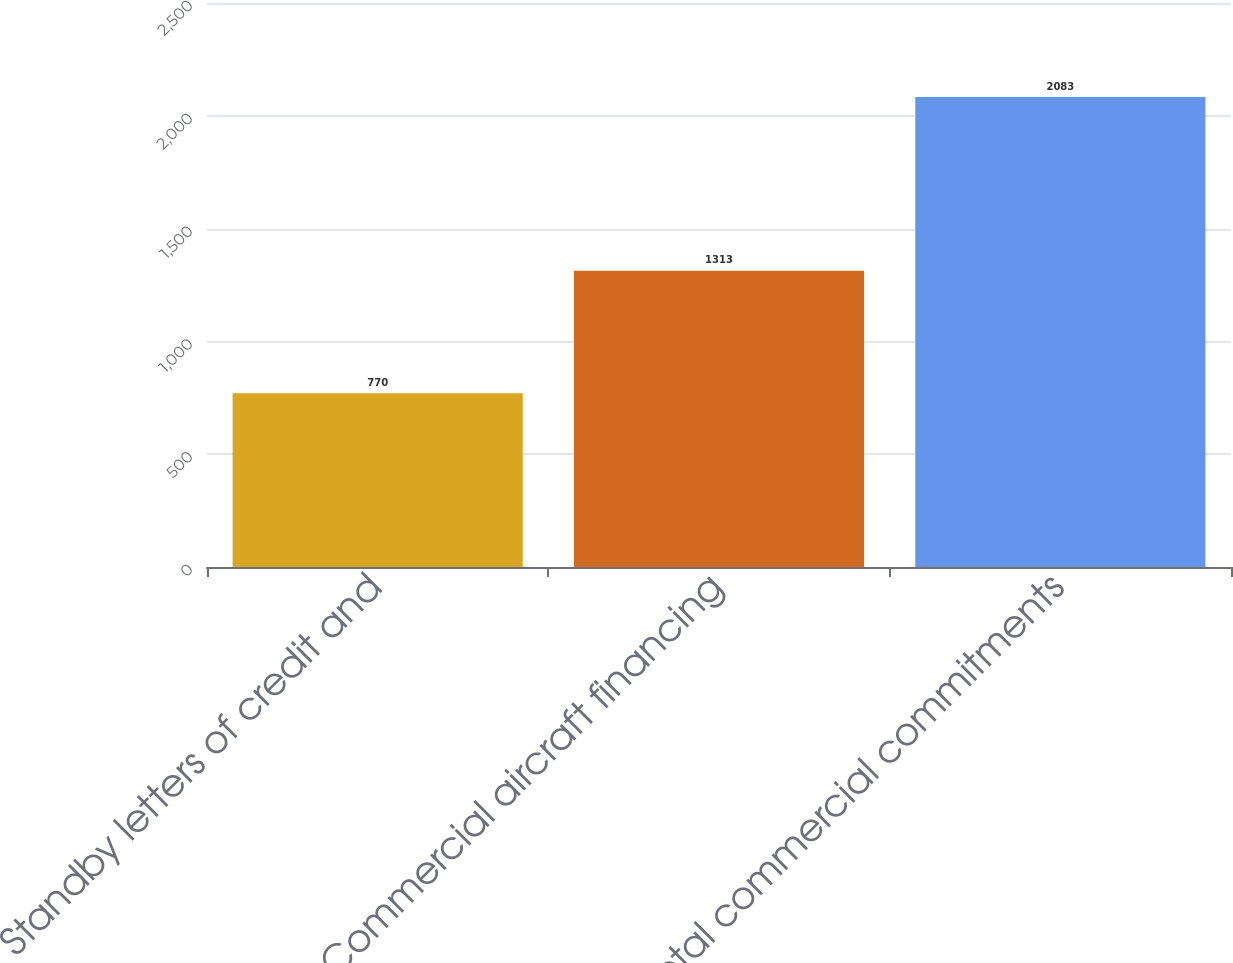Convert chart. <chart><loc_0><loc_0><loc_500><loc_500><bar_chart><fcel>Standby letters of credit and<fcel>Commercial aircraft financing<fcel>Total commercial commitments<nl><fcel>770<fcel>1313<fcel>2083<nl></chart> 